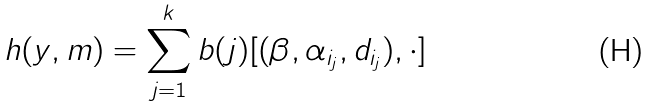Convert formula to latex. <formula><loc_0><loc_0><loc_500><loc_500>h ( y , m ) = \sum _ { j = 1 } ^ { k } b ( j ) [ ( \beta , \alpha _ { i _ { j } } , d _ { i _ { j } } ) , \cdot ]</formula> 